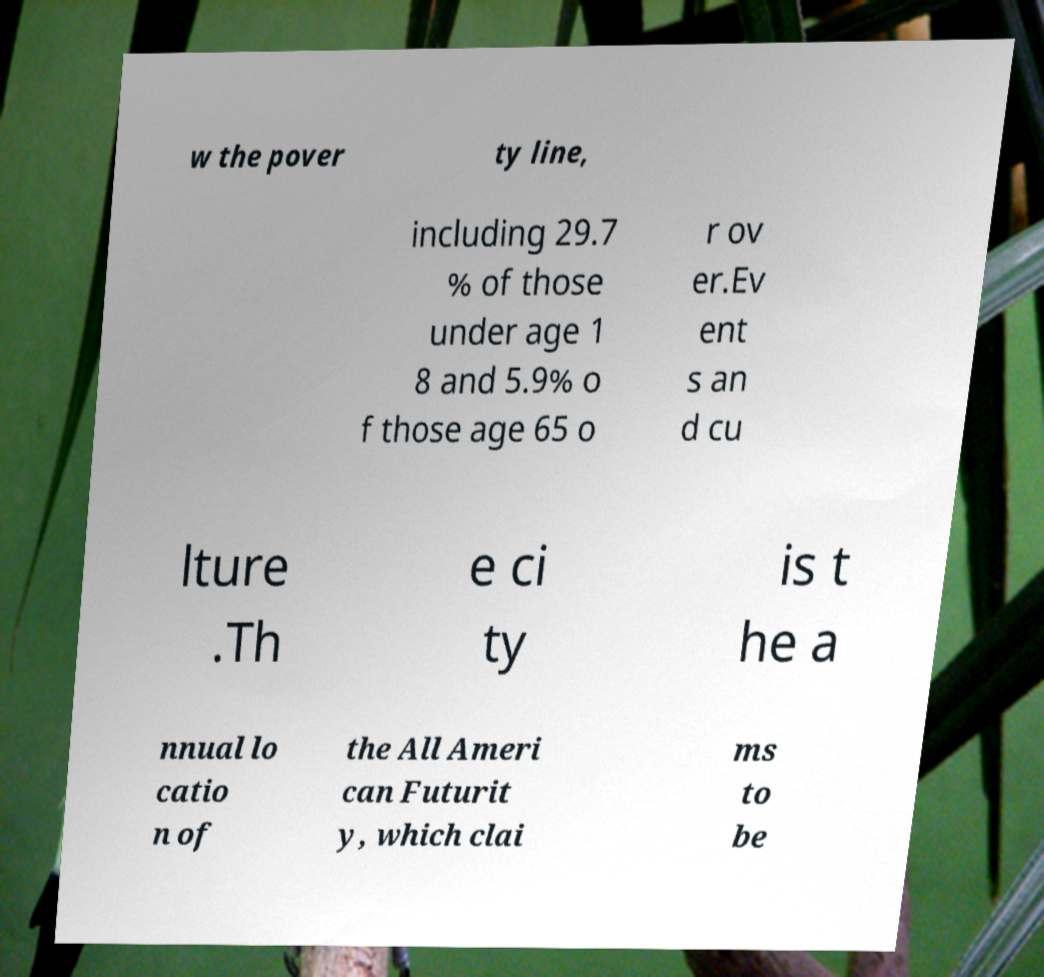I need the written content from this picture converted into text. Can you do that? w the pover ty line, including 29.7 % of those under age 1 8 and 5.9% o f those age 65 o r ov er.Ev ent s an d cu lture .Th e ci ty is t he a nnual lo catio n of the All Ameri can Futurit y, which clai ms to be 